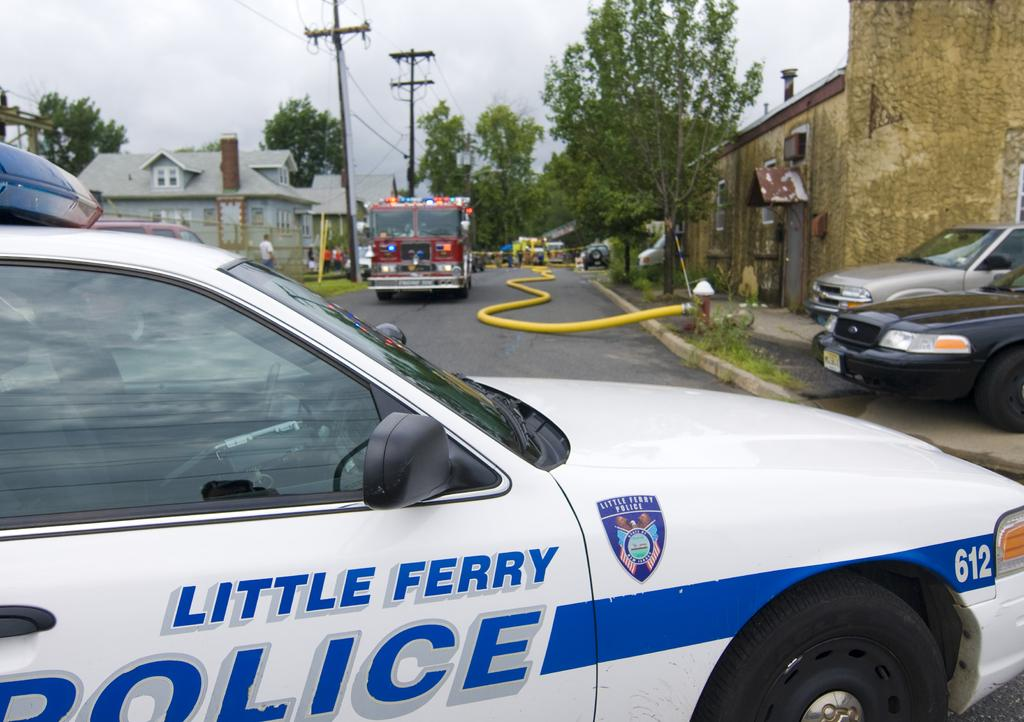What can be seen on the road in the image? There are vehicles on the road in the image. What type of vegetation is present on either side of the road? There are trees on either side of the road. What type of structures are present on either side of the road? There are houses on either side of the road. What other infrastructure can be seen on either side of the road? There are electric poles on either side of the road. What is the water source on the right side of the image? There is a tap with a water pipe on the right side of the image. Where is the stage located in the image? There is no stage present in the image. What type of kite can be seen flying in the image? There is no kite present in the image. 